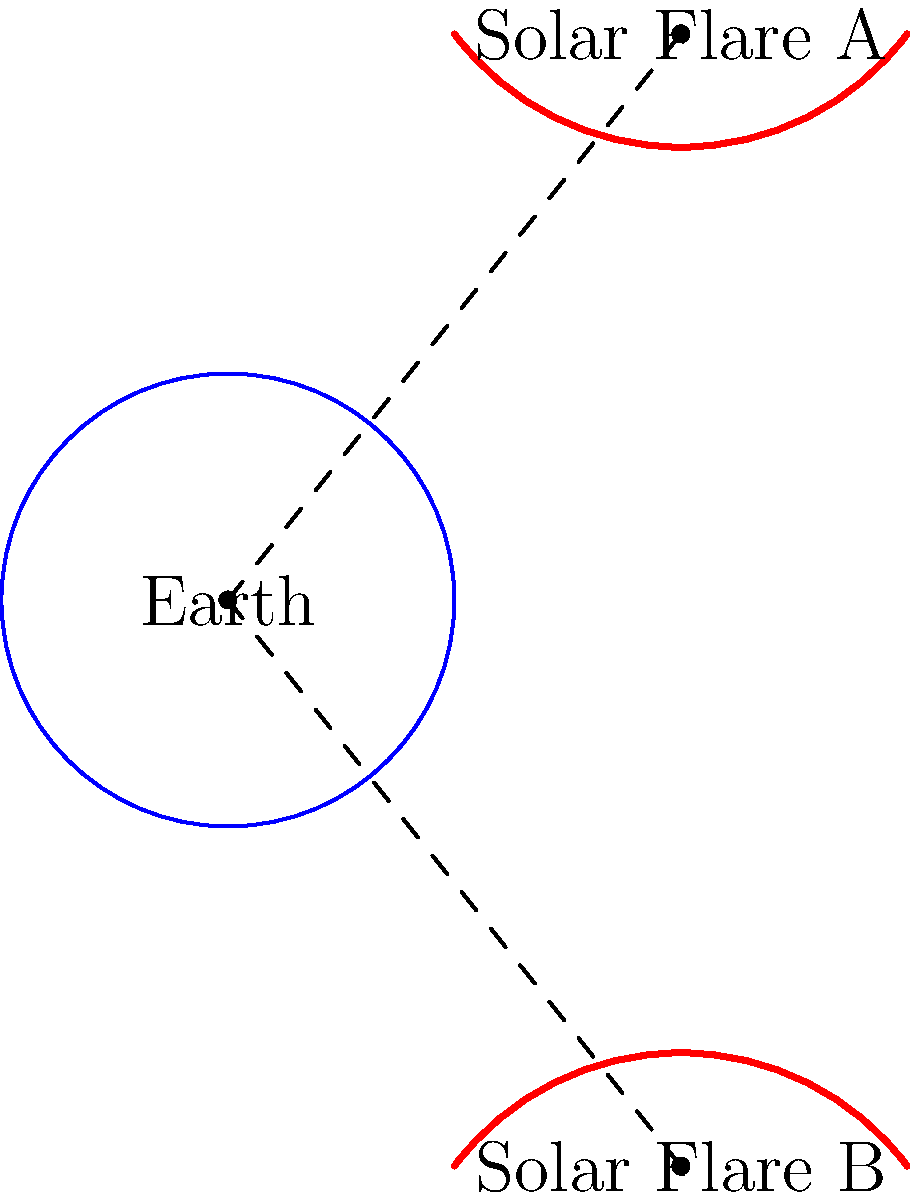Two solar flares, A and B, are observed as shown in the diagram. Both flares have the same arc length but different curvatures. If the impact zone on Earth is determined by the solid angle subtended by the flare, which flare will have a larger impact zone? Explain your reasoning using concepts from differential geometry and solid angle calculations. To determine which solar flare will have a larger impact zone on Earth, we need to consider the solid angle subtended by each flare. The solid angle is a measure of how large an object appears from a given point of view, in this case, from the center of the Earth. Let's approach this step-by-step:

1. Arc length: Both flares have the same arc length, which means the total "size" of the flares is equal.

2. Curvature: Flare A has a higher curvature (it's more "bent") compared to Flare B, which is flatter.

3. Solid angle: The solid angle $\Omega$ subtended by a curve can be approximated by:

   $$\Omega \approx \frac{A}{r^2}$$

   where $A$ is the projected area of the curve onto a sphere centered at the viewpoint, and $r$ is the distance to the curve.

4. Projected area: Due to the higher curvature of Flare A, its projected area onto a sphere centered at Earth will be smaller than that of Flare B, despite having the same arc length.

5. Distance: Both flares appear to be at the same distance from Earth in this 2D representation.

6. Comparison: Since the distances are the same and Flare B has a larger projected area, it will subtend a larger solid angle.

7. Impact zone: The larger solid angle corresponds to a larger impact zone on Earth's surface.

Therefore, Solar Flare B, with its flatter shape, will have a larger impact zone on Earth compared to Solar Flare A.
Answer: Solar Flare B 